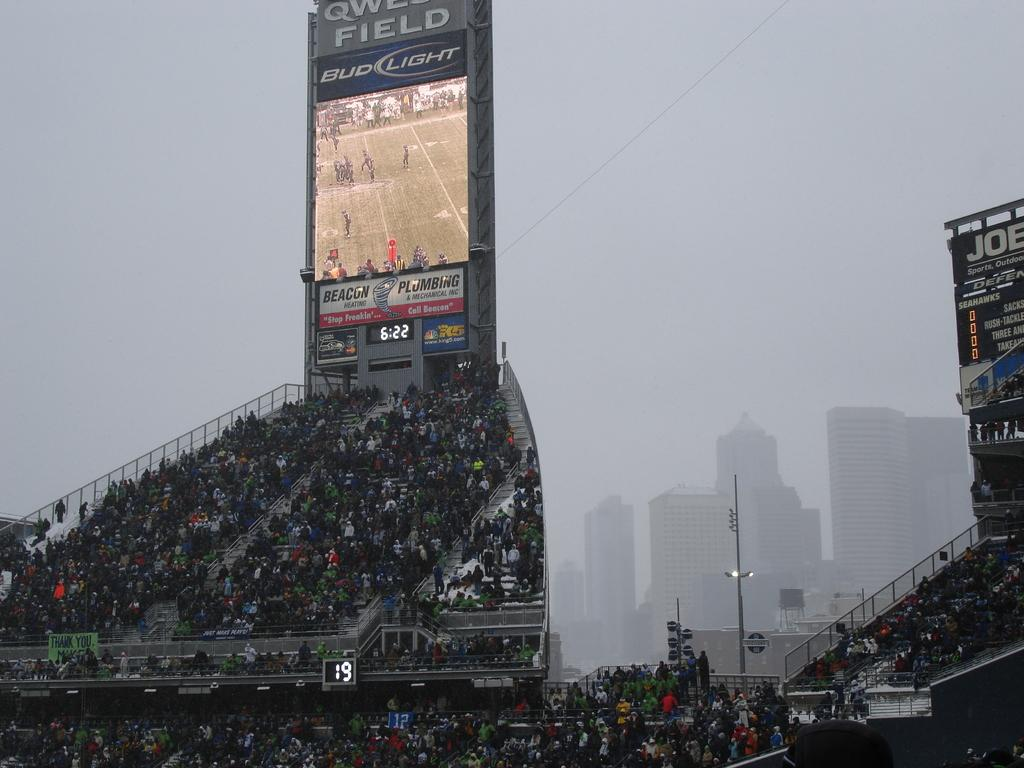<image>
Relay a brief, clear account of the picture shown. A stadium with a tall monitor that says Bud Light on it. 